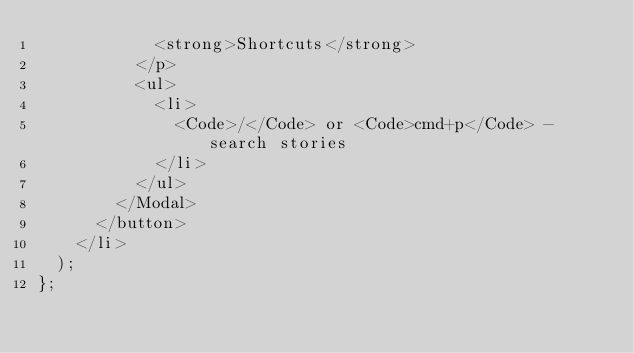Convert code to text. <code><loc_0><loc_0><loc_500><loc_500><_TypeScript_>            <strong>Shortcuts</strong>
          </p>
          <ul>
            <li>
              <Code>/</Code> or <Code>cmd+p</Code> - search stories
            </li>
          </ul>
        </Modal>
      </button>
    </li>
  );
};
</code> 